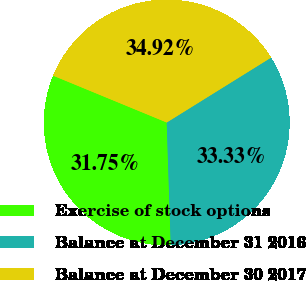Convert chart to OTSL. <chart><loc_0><loc_0><loc_500><loc_500><pie_chart><fcel>Exercise of stock options<fcel>Balance at December 31 2016<fcel>Balance at December 30 2017<nl><fcel>31.75%<fcel>33.33%<fcel>34.92%<nl></chart> 